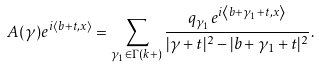<formula> <loc_0><loc_0><loc_500><loc_500>A ( \gamma ) e ^ { i \left \langle b + t , x \right \rangle } = \sum _ { \gamma _ { 1 } \in \Gamma ( k + ) } \frac { q _ { \gamma _ { 1 } } e ^ { i \left \langle b + \gamma _ { 1 } + t , x \right \rangle } } { | \gamma + t | ^ { 2 } - | b + \gamma _ { 1 } + t | ^ { 2 } } .</formula> 